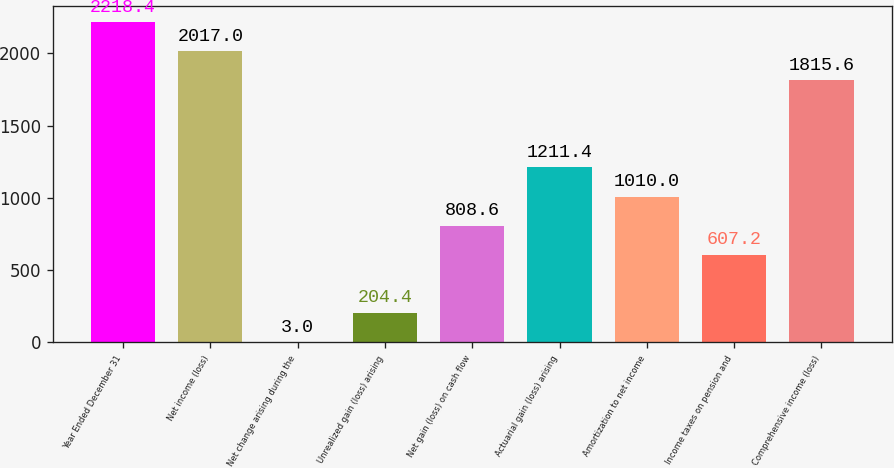<chart> <loc_0><loc_0><loc_500><loc_500><bar_chart><fcel>Year Ended December 31<fcel>Net income (loss)<fcel>Net change arising during the<fcel>Unrealized gain (loss) arising<fcel>Net gain (loss) on cash flow<fcel>Actuarial gain (loss) arising<fcel>Amortization to net income<fcel>Income taxes on pension and<fcel>Comprehensive income (loss)<nl><fcel>2218.4<fcel>2017<fcel>3<fcel>204.4<fcel>808.6<fcel>1211.4<fcel>1010<fcel>607.2<fcel>1815.6<nl></chart> 